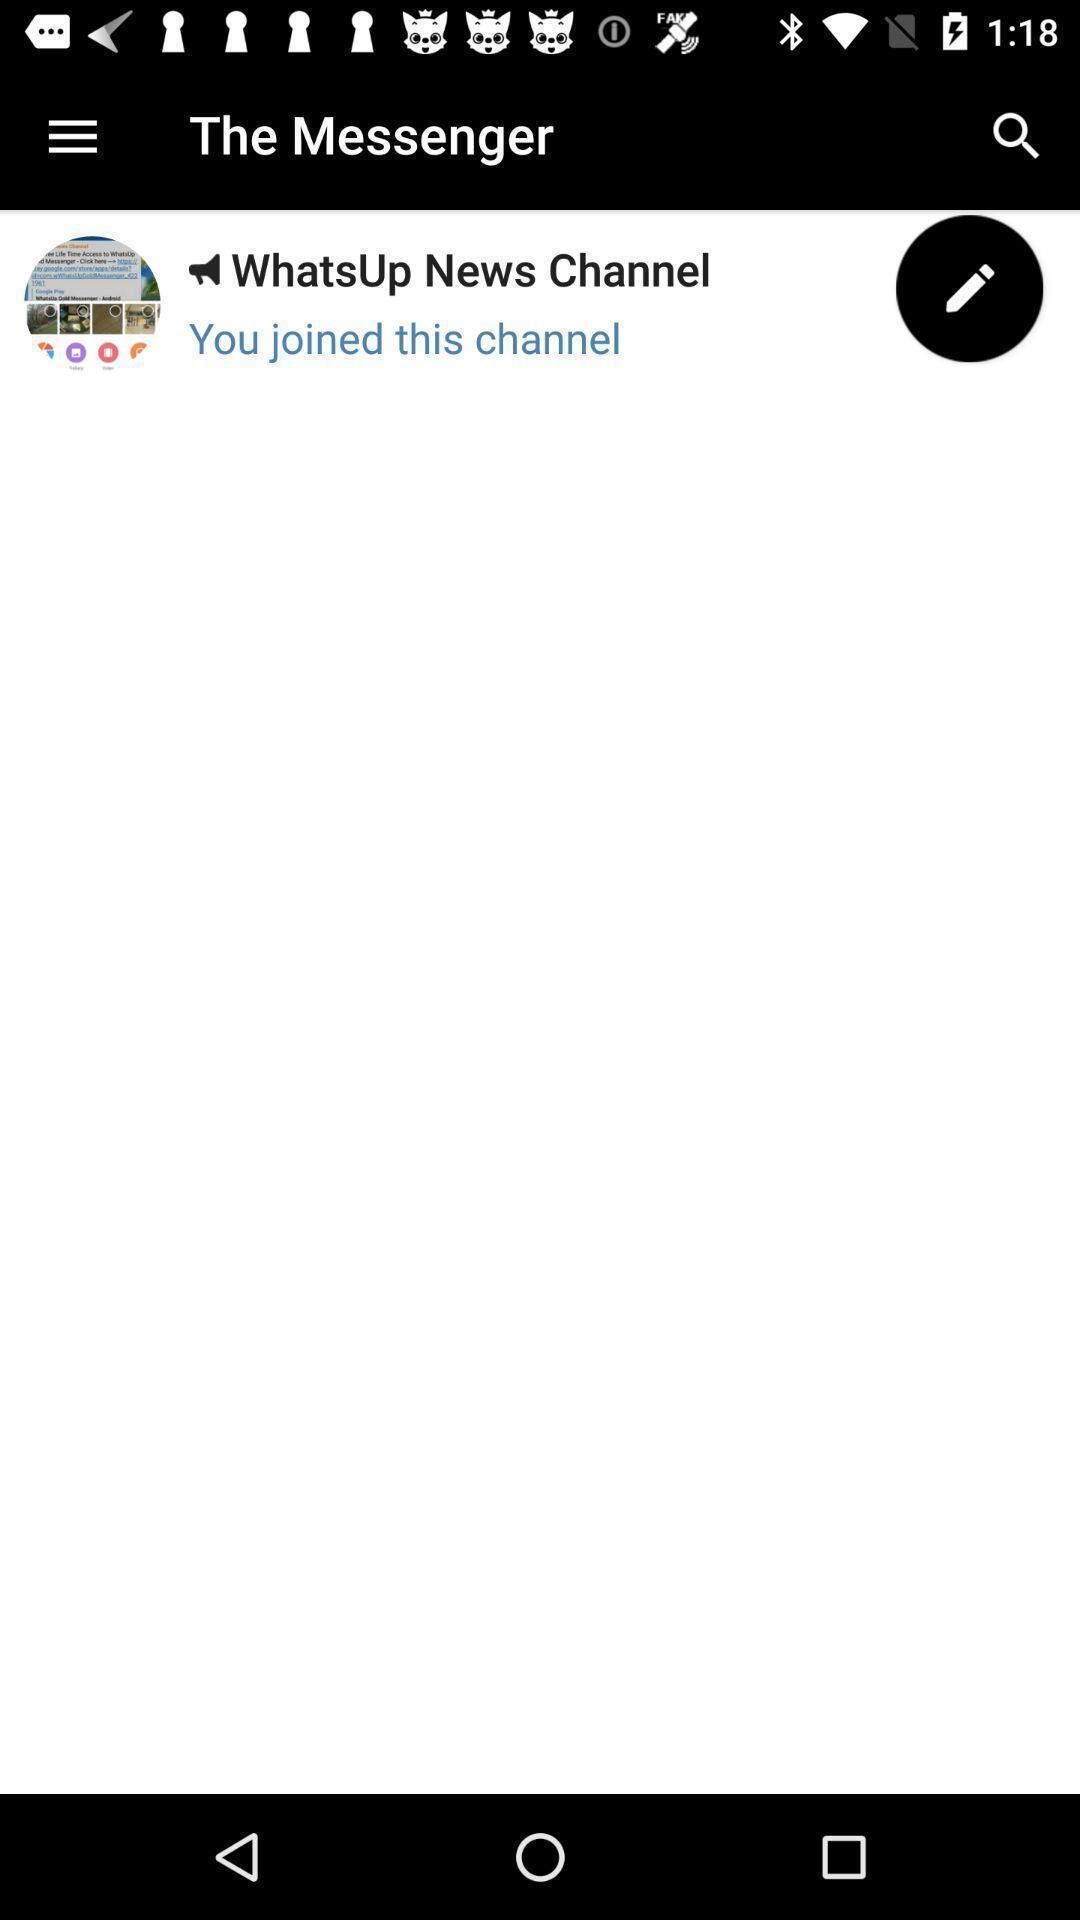What is the overall content of this screenshot? Screen displaying a messenger group of news channel. 